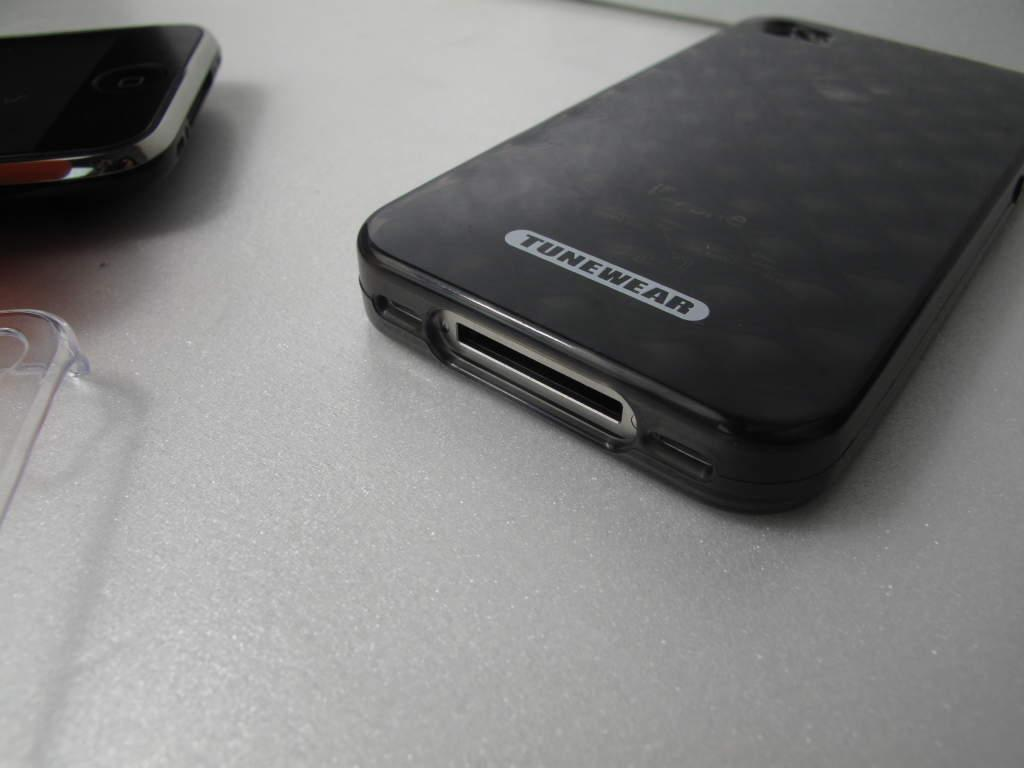What is the color of the object on the table top? The object on the table top is black. What is located beside the black object? There is a black mobile phone beside the black object. What note is the mobile phone playing in the image? There is no indication in the image that the mobile phone is playing any music or note. 